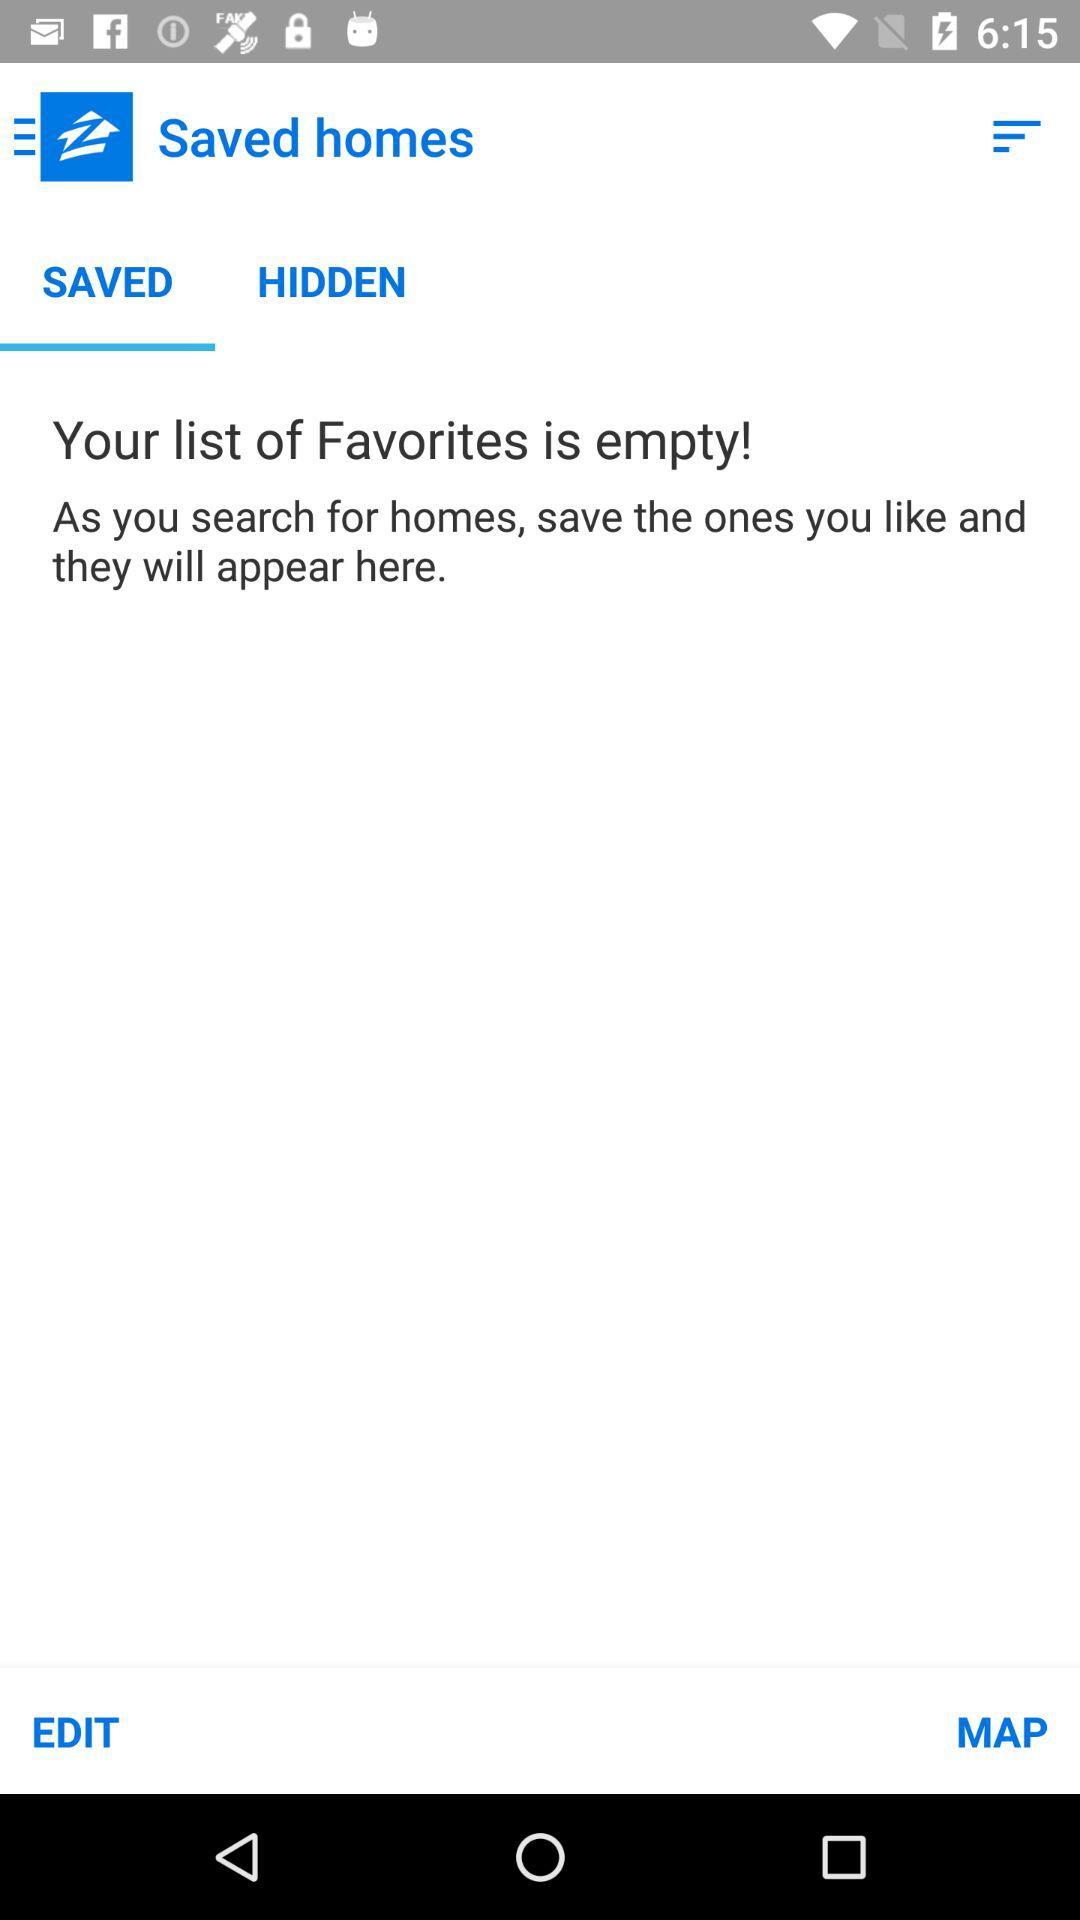What is the open tab? The open tab is "SAVED". 